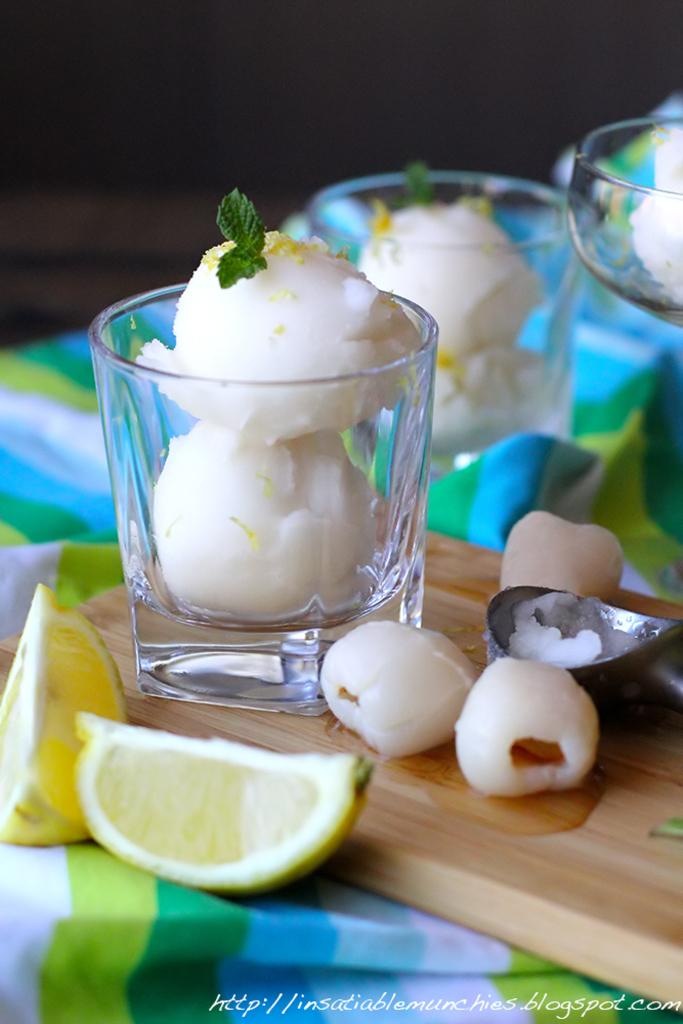What type of fruit is sliced and visible in the image? There is a sliced lemon in the image. What tool is present in the image? There is a scoop in the image. What surface is the lemon and scoop placed on? There is a wooden chopping board in the image. What type of containers are present in the image? There are glasses with food items in the image. Where are the objects located in the image? The objects are on a table. Is there any text in the image? Yes, there is some text at the bottom of the image. What type of addition is being performed with the lemon in the image? There is no addition or any mathematical operation being performed with the lemon in the image. 